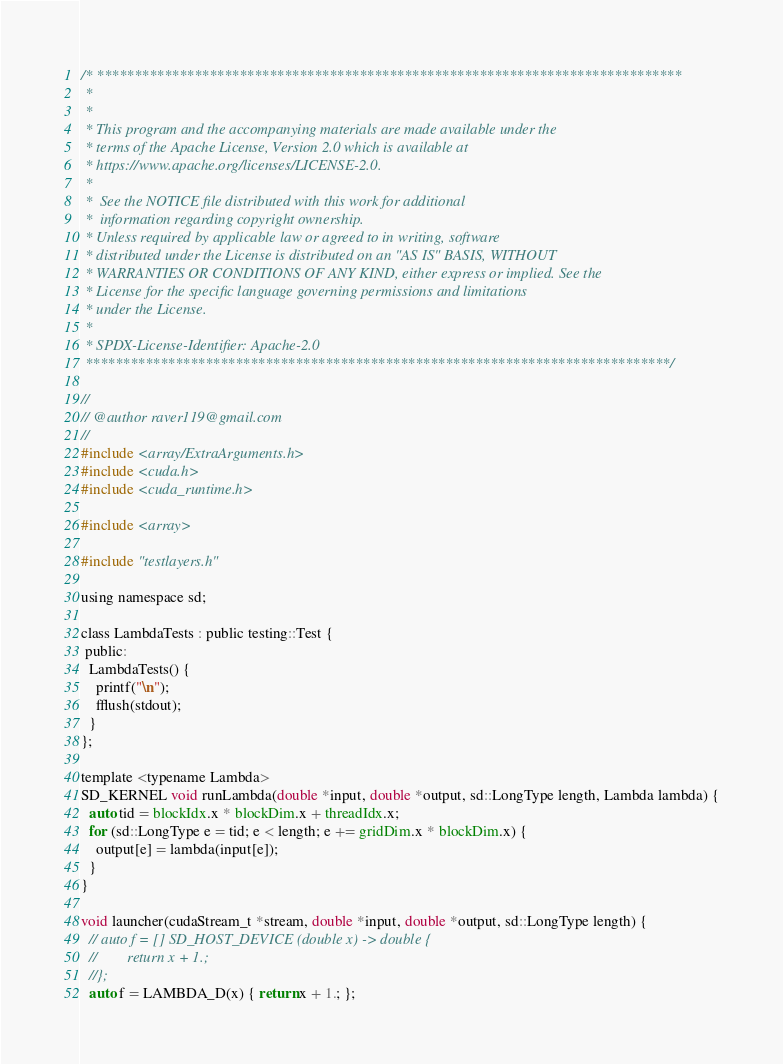Convert code to text. <code><loc_0><loc_0><loc_500><loc_500><_Cuda_>/* ******************************************************************************
 *
 *
 * This program and the accompanying materials are made available under the
 * terms of the Apache License, Version 2.0 which is available at
 * https://www.apache.org/licenses/LICENSE-2.0.
 *
 *  See the NOTICE file distributed with this work for additional
 *  information regarding copyright ownership.
 * Unless required by applicable law or agreed to in writing, software
 * distributed under the License is distributed on an "AS IS" BASIS, WITHOUT
 * WARRANTIES OR CONDITIONS OF ANY KIND, either express or implied. See the
 * License for the specific language governing permissions and limitations
 * under the License.
 *
 * SPDX-License-Identifier: Apache-2.0
 ******************************************************************************/

//
// @author raver119@gmail.com
//
#include <array/ExtraArguments.h>
#include <cuda.h>
#include <cuda_runtime.h>

#include <array>

#include "testlayers.h"

using namespace sd;

class LambdaTests : public testing::Test {
 public:
  LambdaTests() {
    printf("\n");
    fflush(stdout);
  }
};

template <typename Lambda>
SD_KERNEL void runLambda(double *input, double *output, sd::LongType length, Lambda lambda) {
  auto tid = blockIdx.x * blockDim.x + threadIdx.x;
  for (sd::LongType e = tid; e < length; e += gridDim.x * blockDim.x) {
    output[e] = lambda(input[e]);
  }
}

void launcher(cudaStream_t *stream, double *input, double *output, sd::LongType length) {
  // auto f = [] SD_HOST_DEVICE (double x) -> double {
  //        return x + 1.;
  //};
  auto f = LAMBDA_D(x) { return x + 1.; };
</code> 